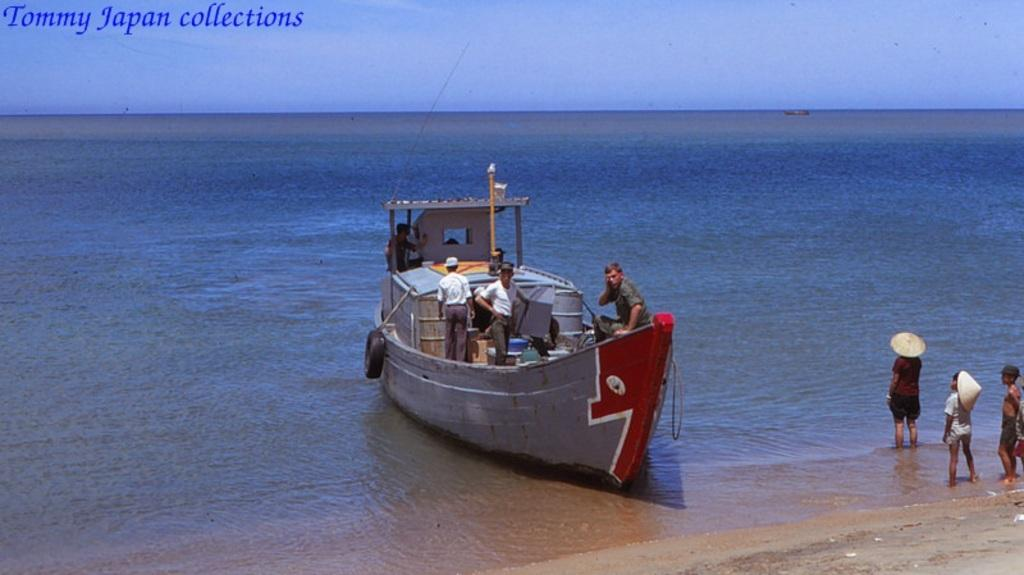What is the main subject of the image? The main subject of the image is water. What is located on the water in the image? There is a boat on the water in the image. Who is in the boat? There are people in the boat. What can be seen on the right side of the image? Kids wearing hats can be seen on the right side of the image. What is visible at the top of the image? The sky is visible at the top of the image. How many bikes are being ridden by the kids in the image? There are no bikes present in the image; the kids are wearing hats. What type of spark can be seen coming from the boat in the image? There is no spark coming from the boat in the image; it is a regular boat on the water. 